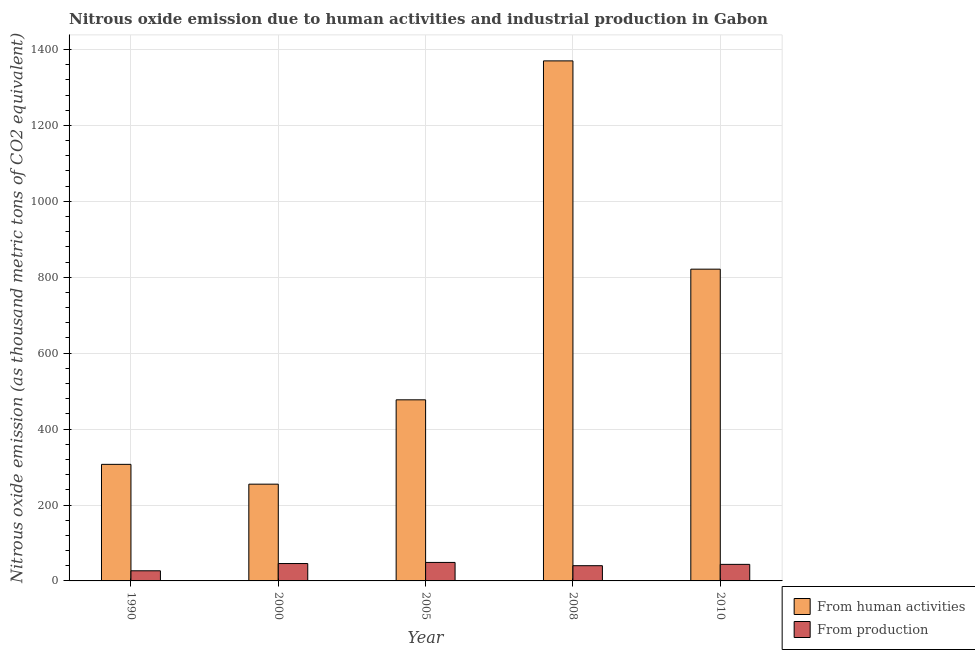How many different coloured bars are there?
Provide a succinct answer. 2. How many groups of bars are there?
Offer a very short reply. 5. Are the number of bars per tick equal to the number of legend labels?
Your response must be concise. Yes. Are the number of bars on each tick of the X-axis equal?
Ensure brevity in your answer.  Yes. How many bars are there on the 5th tick from the left?
Keep it short and to the point. 2. How many bars are there on the 2nd tick from the right?
Make the answer very short. 2. What is the amount of emissions generated from industries in 2010?
Provide a succinct answer. 43.6. Across all years, what is the maximum amount of emissions from human activities?
Ensure brevity in your answer.  1370. Across all years, what is the minimum amount of emissions from human activities?
Offer a very short reply. 254.9. In which year was the amount of emissions generated from industries minimum?
Give a very brief answer. 1990. What is the total amount of emissions generated from industries in the graph?
Your answer should be compact. 204.9. What is the difference between the amount of emissions from human activities in 1990 and that in 2000?
Make the answer very short. 52.2. What is the difference between the amount of emissions generated from industries in 2000 and the amount of emissions from human activities in 2005?
Keep it short and to the point. -2.9. What is the average amount of emissions from human activities per year?
Offer a terse response. 646.08. What is the ratio of the amount of emissions generated from industries in 1990 to that in 2000?
Provide a succinct answer. 0.58. Is the amount of emissions from human activities in 2000 less than that in 2008?
Give a very brief answer. Yes. Is the difference between the amount of emissions generated from industries in 2008 and 2010 greater than the difference between the amount of emissions from human activities in 2008 and 2010?
Your answer should be very brief. No. What is the difference between the highest and the second highest amount of emissions generated from industries?
Give a very brief answer. 2.9. What is the difference between the highest and the lowest amount of emissions from human activities?
Provide a short and direct response. 1115.1. What does the 2nd bar from the left in 2000 represents?
Provide a short and direct response. From production. What does the 2nd bar from the right in 2010 represents?
Your answer should be compact. From human activities. How many bars are there?
Your response must be concise. 10. What is the difference between two consecutive major ticks on the Y-axis?
Offer a very short reply. 200. Does the graph contain any zero values?
Make the answer very short. No. How are the legend labels stacked?
Your answer should be very brief. Vertical. What is the title of the graph?
Your answer should be compact. Nitrous oxide emission due to human activities and industrial production in Gabon. What is the label or title of the X-axis?
Provide a short and direct response. Year. What is the label or title of the Y-axis?
Keep it short and to the point. Nitrous oxide emission (as thousand metric tons of CO2 equivalent). What is the Nitrous oxide emission (as thousand metric tons of CO2 equivalent) of From human activities in 1990?
Give a very brief answer. 307.1. What is the Nitrous oxide emission (as thousand metric tons of CO2 equivalent) in From production in 1990?
Give a very brief answer. 26.7. What is the Nitrous oxide emission (as thousand metric tons of CO2 equivalent) in From human activities in 2000?
Give a very brief answer. 254.9. What is the Nitrous oxide emission (as thousand metric tons of CO2 equivalent) of From production in 2000?
Make the answer very short. 45.8. What is the Nitrous oxide emission (as thousand metric tons of CO2 equivalent) in From human activities in 2005?
Your response must be concise. 477.1. What is the Nitrous oxide emission (as thousand metric tons of CO2 equivalent) in From production in 2005?
Your response must be concise. 48.7. What is the Nitrous oxide emission (as thousand metric tons of CO2 equivalent) of From human activities in 2008?
Ensure brevity in your answer.  1370. What is the Nitrous oxide emission (as thousand metric tons of CO2 equivalent) in From production in 2008?
Your answer should be very brief. 40.1. What is the Nitrous oxide emission (as thousand metric tons of CO2 equivalent) of From human activities in 2010?
Give a very brief answer. 821.3. What is the Nitrous oxide emission (as thousand metric tons of CO2 equivalent) in From production in 2010?
Make the answer very short. 43.6. Across all years, what is the maximum Nitrous oxide emission (as thousand metric tons of CO2 equivalent) in From human activities?
Give a very brief answer. 1370. Across all years, what is the maximum Nitrous oxide emission (as thousand metric tons of CO2 equivalent) of From production?
Ensure brevity in your answer.  48.7. Across all years, what is the minimum Nitrous oxide emission (as thousand metric tons of CO2 equivalent) of From human activities?
Ensure brevity in your answer.  254.9. Across all years, what is the minimum Nitrous oxide emission (as thousand metric tons of CO2 equivalent) in From production?
Offer a terse response. 26.7. What is the total Nitrous oxide emission (as thousand metric tons of CO2 equivalent) of From human activities in the graph?
Your response must be concise. 3230.4. What is the total Nitrous oxide emission (as thousand metric tons of CO2 equivalent) in From production in the graph?
Your response must be concise. 204.9. What is the difference between the Nitrous oxide emission (as thousand metric tons of CO2 equivalent) in From human activities in 1990 and that in 2000?
Provide a short and direct response. 52.2. What is the difference between the Nitrous oxide emission (as thousand metric tons of CO2 equivalent) of From production in 1990 and that in 2000?
Your answer should be compact. -19.1. What is the difference between the Nitrous oxide emission (as thousand metric tons of CO2 equivalent) of From human activities in 1990 and that in 2005?
Keep it short and to the point. -170. What is the difference between the Nitrous oxide emission (as thousand metric tons of CO2 equivalent) of From production in 1990 and that in 2005?
Offer a very short reply. -22. What is the difference between the Nitrous oxide emission (as thousand metric tons of CO2 equivalent) of From human activities in 1990 and that in 2008?
Your answer should be very brief. -1062.9. What is the difference between the Nitrous oxide emission (as thousand metric tons of CO2 equivalent) in From production in 1990 and that in 2008?
Keep it short and to the point. -13.4. What is the difference between the Nitrous oxide emission (as thousand metric tons of CO2 equivalent) in From human activities in 1990 and that in 2010?
Offer a very short reply. -514.2. What is the difference between the Nitrous oxide emission (as thousand metric tons of CO2 equivalent) of From production in 1990 and that in 2010?
Give a very brief answer. -16.9. What is the difference between the Nitrous oxide emission (as thousand metric tons of CO2 equivalent) in From human activities in 2000 and that in 2005?
Your answer should be very brief. -222.2. What is the difference between the Nitrous oxide emission (as thousand metric tons of CO2 equivalent) of From production in 2000 and that in 2005?
Your response must be concise. -2.9. What is the difference between the Nitrous oxide emission (as thousand metric tons of CO2 equivalent) in From human activities in 2000 and that in 2008?
Provide a short and direct response. -1115.1. What is the difference between the Nitrous oxide emission (as thousand metric tons of CO2 equivalent) of From human activities in 2000 and that in 2010?
Your response must be concise. -566.4. What is the difference between the Nitrous oxide emission (as thousand metric tons of CO2 equivalent) in From production in 2000 and that in 2010?
Your response must be concise. 2.2. What is the difference between the Nitrous oxide emission (as thousand metric tons of CO2 equivalent) of From human activities in 2005 and that in 2008?
Keep it short and to the point. -892.9. What is the difference between the Nitrous oxide emission (as thousand metric tons of CO2 equivalent) of From human activities in 2005 and that in 2010?
Ensure brevity in your answer.  -344.2. What is the difference between the Nitrous oxide emission (as thousand metric tons of CO2 equivalent) in From human activities in 2008 and that in 2010?
Make the answer very short. 548.7. What is the difference between the Nitrous oxide emission (as thousand metric tons of CO2 equivalent) in From human activities in 1990 and the Nitrous oxide emission (as thousand metric tons of CO2 equivalent) in From production in 2000?
Offer a terse response. 261.3. What is the difference between the Nitrous oxide emission (as thousand metric tons of CO2 equivalent) of From human activities in 1990 and the Nitrous oxide emission (as thousand metric tons of CO2 equivalent) of From production in 2005?
Provide a succinct answer. 258.4. What is the difference between the Nitrous oxide emission (as thousand metric tons of CO2 equivalent) in From human activities in 1990 and the Nitrous oxide emission (as thousand metric tons of CO2 equivalent) in From production in 2008?
Offer a terse response. 267. What is the difference between the Nitrous oxide emission (as thousand metric tons of CO2 equivalent) in From human activities in 1990 and the Nitrous oxide emission (as thousand metric tons of CO2 equivalent) in From production in 2010?
Offer a terse response. 263.5. What is the difference between the Nitrous oxide emission (as thousand metric tons of CO2 equivalent) of From human activities in 2000 and the Nitrous oxide emission (as thousand metric tons of CO2 equivalent) of From production in 2005?
Offer a very short reply. 206.2. What is the difference between the Nitrous oxide emission (as thousand metric tons of CO2 equivalent) of From human activities in 2000 and the Nitrous oxide emission (as thousand metric tons of CO2 equivalent) of From production in 2008?
Your answer should be compact. 214.8. What is the difference between the Nitrous oxide emission (as thousand metric tons of CO2 equivalent) in From human activities in 2000 and the Nitrous oxide emission (as thousand metric tons of CO2 equivalent) in From production in 2010?
Ensure brevity in your answer.  211.3. What is the difference between the Nitrous oxide emission (as thousand metric tons of CO2 equivalent) of From human activities in 2005 and the Nitrous oxide emission (as thousand metric tons of CO2 equivalent) of From production in 2008?
Make the answer very short. 437. What is the difference between the Nitrous oxide emission (as thousand metric tons of CO2 equivalent) of From human activities in 2005 and the Nitrous oxide emission (as thousand metric tons of CO2 equivalent) of From production in 2010?
Provide a short and direct response. 433.5. What is the difference between the Nitrous oxide emission (as thousand metric tons of CO2 equivalent) in From human activities in 2008 and the Nitrous oxide emission (as thousand metric tons of CO2 equivalent) in From production in 2010?
Your response must be concise. 1326.4. What is the average Nitrous oxide emission (as thousand metric tons of CO2 equivalent) in From human activities per year?
Offer a terse response. 646.08. What is the average Nitrous oxide emission (as thousand metric tons of CO2 equivalent) in From production per year?
Provide a succinct answer. 40.98. In the year 1990, what is the difference between the Nitrous oxide emission (as thousand metric tons of CO2 equivalent) in From human activities and Nitrous oxide emission (as thousand metric tons of CO2 equivalent) in From production?
Offer a terse response. 280.4. In the year 2000, what is the difference between the Nitrous oxide emission (as thousand metric tons of CO2 equivalent) of From human activities and Nitrous oxide emission (as thousand metric tons of CO2 equivalent) of From production?
Make the answer very short. 209.1. In the year 2005, what is the difference between the Nitrous oxide emission (as thousand metric tons of CO2 equivalent) of From human activities and Nitrous oxide emission (as thousand metric tons of CO2 equivalent) of From production?
Provide a succinct answer. 428.4. In the year 2008, what is the difference between the Nitrous oxide emission (as thousand metric tons of CO2 equivalent) of From human activities and Nitrous oxide emission (as thousand metric tons of CO2 equivalent) of From production?
Your answer should be very brief. 1329.9. In the year 2010, what is the difference between the Nitrous oxide emission (as thousand metric tons of CO2 equivalent) in From human activities and Nitrous oxide emission (as thousand metric tons of CO2 equivalent) in From production?
Offer a terse response. 777.7. What is the ratio of the Nitrous oxide emission (as thousand metric tons of CO2 equivalent) in From human activities in 1990 to that in 2000?
Give a very brief answer. 1.2. What is the ratio of the Nitrous oxide emission (as thousand metric tons of CO2 equivalent) of From production in 1990 to that in 2000?
Offer a terse response. 0.58. What is the ratio of the Nitrous oxide emission (as thousand metric tons of CO2 equivalent) in From human activities in 1990 to that in 2005?
Ensure brevity in your answer.  0.64. What is the ratio of the Nitrous oxide emission (as thousand metric tons of CO2 equivalent) of From production in 1990 to that in 2005?
Your answer should be compact. 0.55. What is the ratio of the Nitrous oxide emission (as thousand metric tons of CO2 equivalent) of From human activities in 1990 to that in 2008?
Provide a short and direct response. 0.22. What is the ratio of the Nitrous oxide emission (as thousand metric tons of CO2 equivalent) in From production in 1990 to that in 2008?
Your answer should be compact. 0.67. What is the ratio of the Nitrous oxide emission (as thousand metric tons of CO2 equivalent) of From human activities in 1990 to that in 2010?
Offer a very short reply. 0.37. What is the ratio of the Nitrous oxide emission (as thousand metric tons of CO2 equivalent) in From production in 1990 to that in 2010?
Your answer should be very brief. 0.61. What is the ratio of the Nitrous oxide emission (as thousand metric tons of CO2 equivalent) in From human activities in 2000 to that in 2005?
Your answer should be compact. 0.53. What is the ratio of the Nitrous oxide emission (as thousand metric tons of CO2 equivalent) in From production in 2000 to that in 2005?
Provide a short and direct response. 0.94. What is the ratio of the Nitrous oxide emission (as thousand metric tons of CO2 equivalent) of From human activities in 2000 to that in 2008?
Offer a terse response. 0.19. What is the ratio of the Nitrous oxide emission (as thousand metric tons of CO2 equivalent) of From production in 2000 to that in 2008?
Provide a short and direct response. 1.14. What is the ratio of the Nitrous oxide emission (as thousand metric tons of CO2 equivalent) in From human activities in 2000 to that in 2010?
Keep it short and to the point. 0.31. What is the ratio of the Nitrous oxide emission (as thousand metric tons of CO2 equivalent) in From production in 2000 to that in 2010?
Your answer should be very brief. 1.05. What is the ratio of the Nitrous oxide emission (as thousand metric tons of CO2 equivalent) of From human activities in 2005 to that in 2008?
Make the answer very short. 0.35. What is the ratio of the Nitrous oxide emission (as thousand metric tons of CO2 equivalent) of From production in 2005 to that in 2008?
Ensure brevity in your answer.  1.21. What is the ratio of the Nitrous oxide emission (as thousand metric tons of CO2 equivalent) in From human activities in 2005 to that in 2010?
Your answer should be very brief. 0.58. What is the ratio of the Nitrous oxide emission (as thousand metric tons of CO2 equivalent) in From production in 2005 to that in 2010?
Provide a short and direct response. 1.12. What is the ratio of the Nitrous oxide emission (as thousand metric tons of CO2 equivalent) in From human activities in 2008 to that in 2010?
Your answer should be very brief. 1.67. What is the ratio of the Nitrous oxide emission (as thousand metric tons of CO2 equivalent) of From production in 2008 to that in 2010?
Provide a succinct answer. 0.92. What is the difference between the highest and the second highest Nitrous oxide emission (as thousand metric tons of CO2 equivalent) of From human activities?
Provide a succinct answer. 548.7. What is the difference between the highest and the second highest Nitrous oxide emission (as thousand metric tons of CO2 equivalent) in From production?
Ensure brevity in your answer.  2.9. What is the difference between the highest and the lowest Nitrous oxide emission (as thousand metric tons of CO2 equivalent) in From human activities?
Your answer should be very brief. 1115.1. What is the difference between the highest and the lowest Nitrous oxide emission (as thousand metric tons of CO2 equivalent) of From production?
Your response must be concise. 22. 